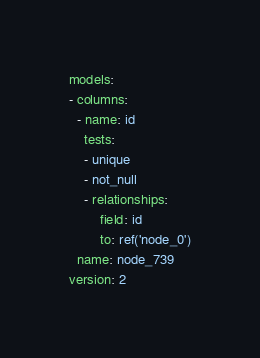<code> <loc_0><loc_0><loc_500><loc_500><_YAML_>models:
- columns:
  - name: id
    tests:
    - unique
    - not_null
    - relationships:
        field: id
        to: ref('node_0')
  name: node_739
version: 2
</code> 